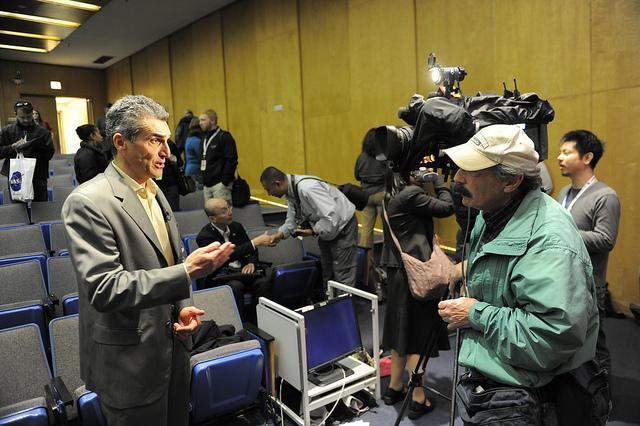How many chairs can you see?
Give a very brief answer. 6. How many people are in the picture?
Give a very brief answer. 9. 